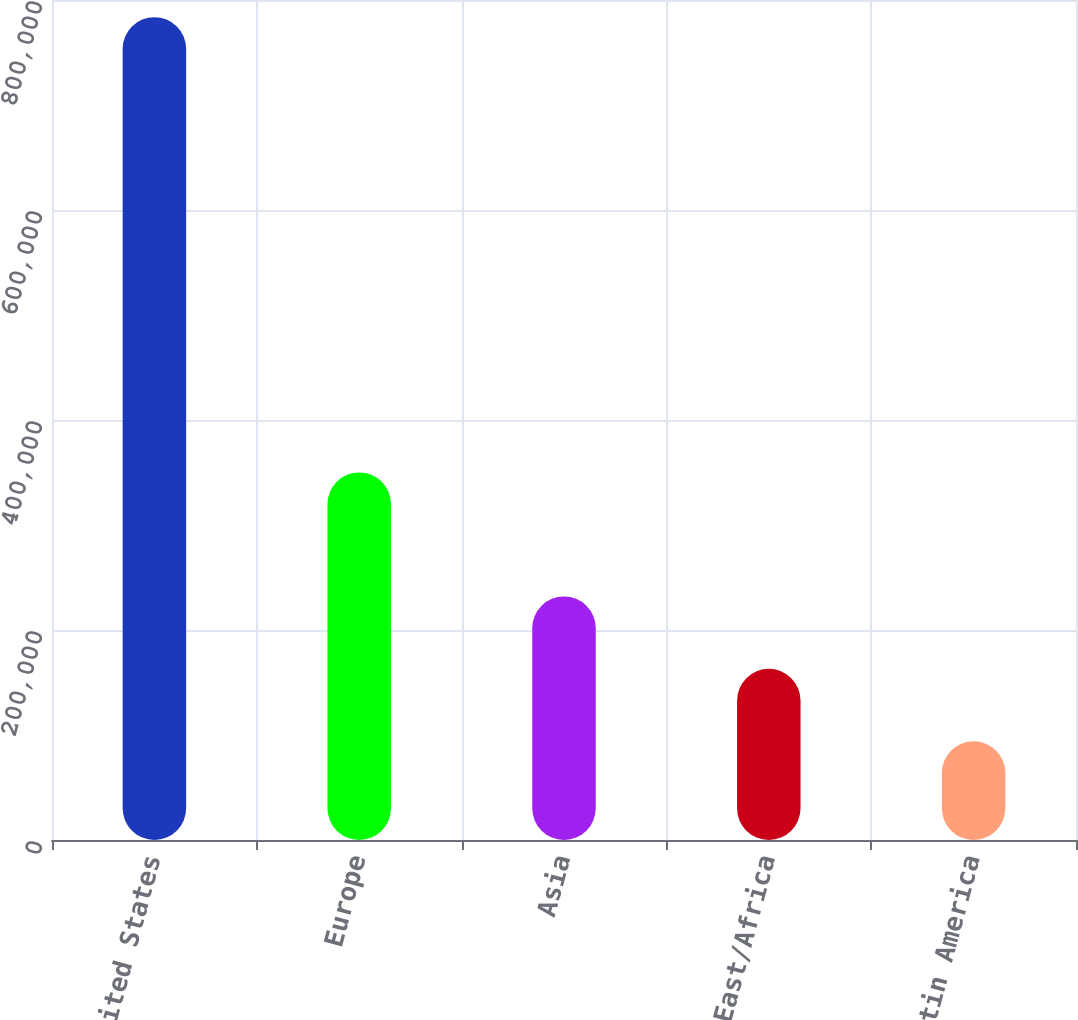<chart> <loc_0><loc_0><loc_500><loc_500><bar_chart><fcel>United States<fcel>Europe<fcel>Asia<fcel>Middle East/Africa<fcel>Canada/Latin America<nl><fcel>783685<fcel>350118<fcel>231963<fcel>162997<fcel>94032<nl></chart> 